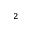Convert formula to latex. <formula><loc_0><loc_0><loc_500><loc_500>_ { 2 }</formula> 